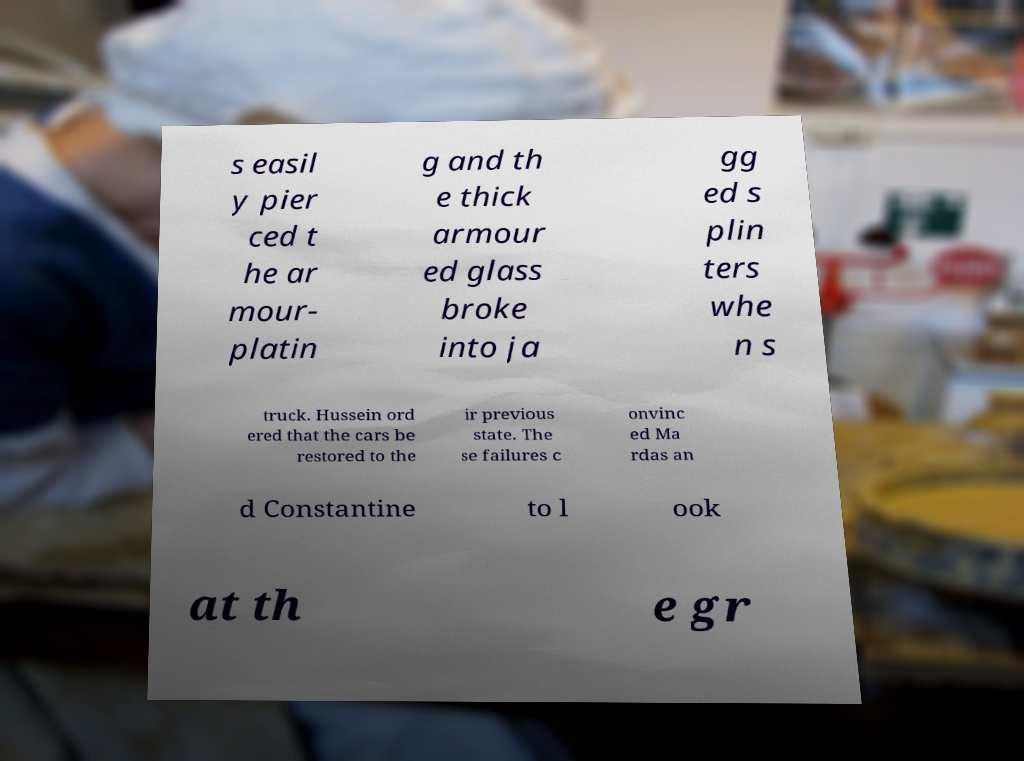There's text embedded in this image that I need extracted. Can you transcribe it verbatim? s easil y pier ced t he ar mour- platin g and th e thick armour ed glass broke into ja gg ed s plin ters whe n s truck. Hussein ord ered that the cars be restored to the ir previous state. The se failures c onvinc ed Ma rdas an d Constantine to l ook at th e gr 